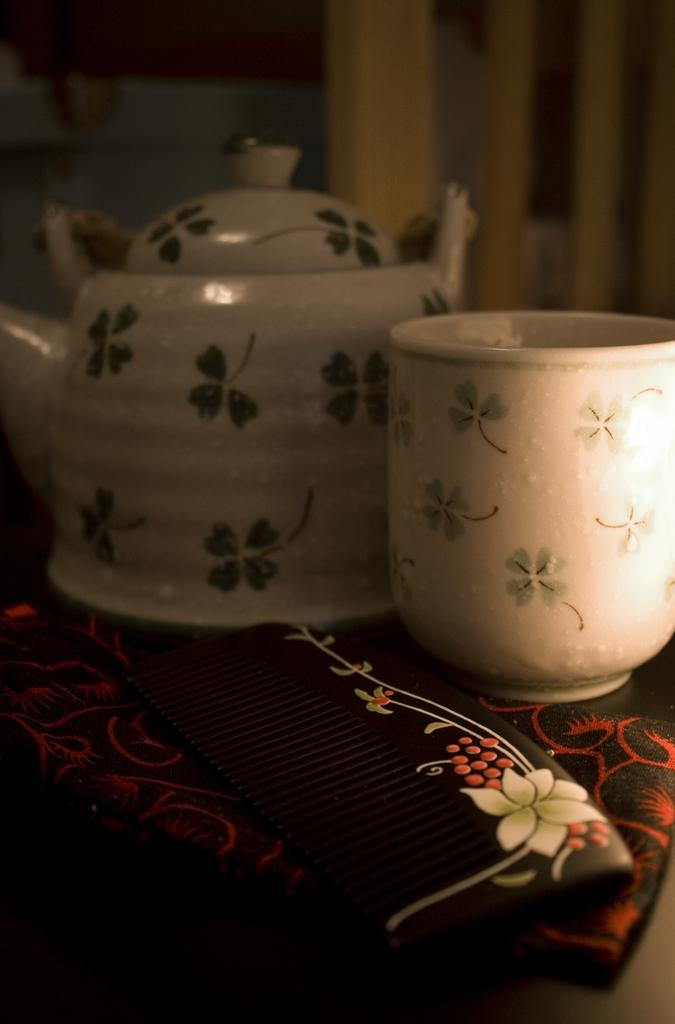What type of kitchen appliance is present in the image? There is a kettle in the image. What can be used for drinking in the image? There is a cup in the image. What is used for grooming in the image? There is a comb in the image. What type of yoke is visible in the image? There is no yoke present in the image. How many boots are visible in the image? There are no boots present in the image. 